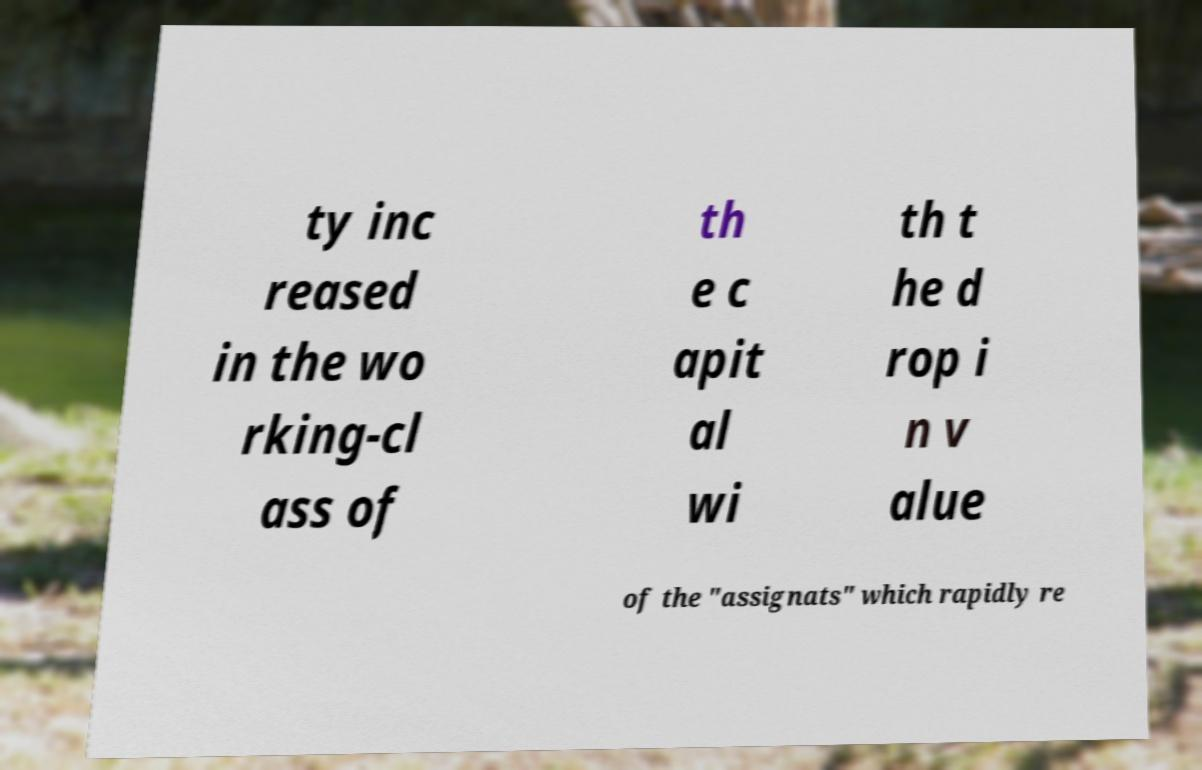Could you extract and type out the text from this image? ty inc reased in the wo rking-cl ass of th e c apit al wi th t he d rop i n v alue of the "assignats" which rapidly re 